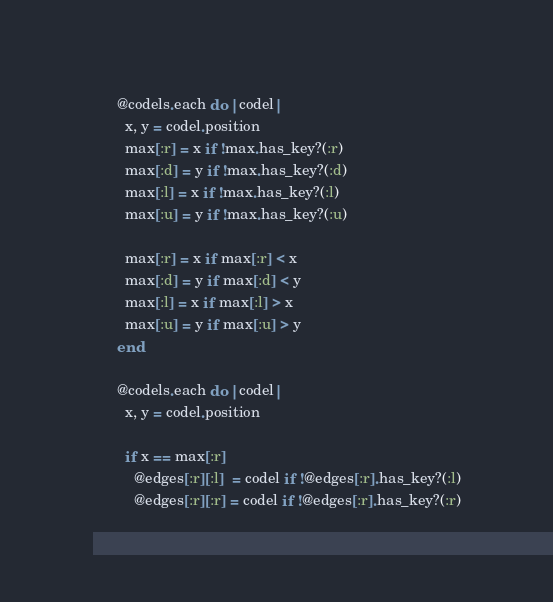<code> <loc_0><loc_0><loc_500><loc_500><_Crystal_>      @codels.each do |codel|
        x, y = codel.position
        max[:r] = x if !max.has_key?(:r)
        max[:d] = y if !max.has_key?(:d)
        max[:l] = x if !max.has_key?(:l)
        max[:u] = y if !max.has_key?(:u)

        max[:r] = x if max[:r] < x
        max[:d] = y if max[:d] < y
        max[:l] = x if max[:l] > x
        max[:u] = y if max[:u] > y
      end

      @codels.each do |codel|
        x, y = codel.position

        if x == max[:r]
          @edges[:r][:l]  = codel if !@edges[:r].has_key?(:l)
          @edges[:r][:r] = codel if !@edges[:r].has_key?(:r)
</code> 